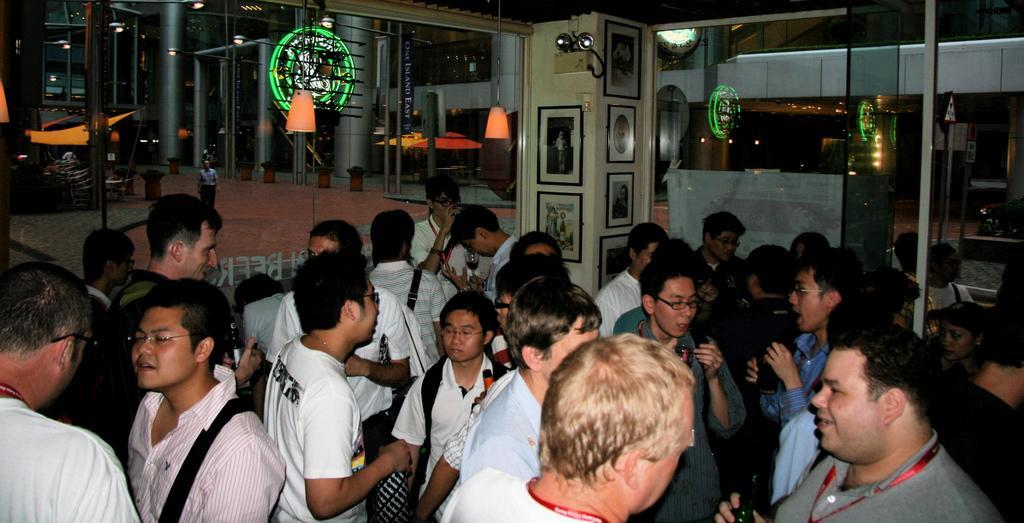Can you describe this image briefly? In this image there are some persons standing at bottom of this image and there are some glass doors at top of this image. 